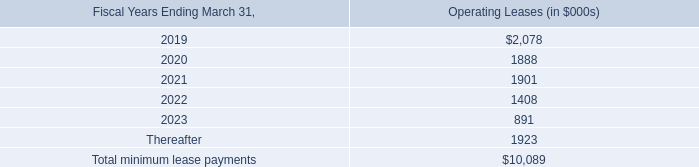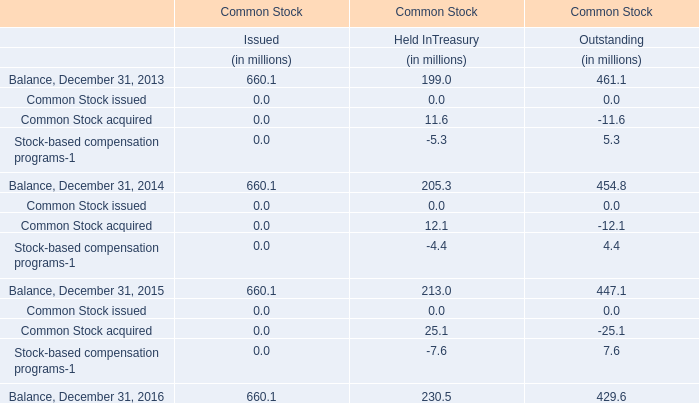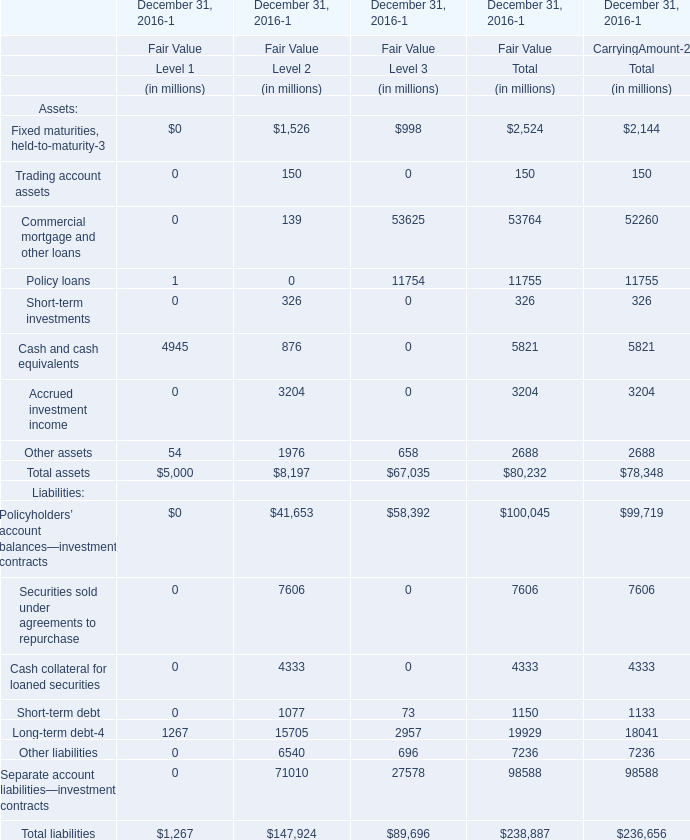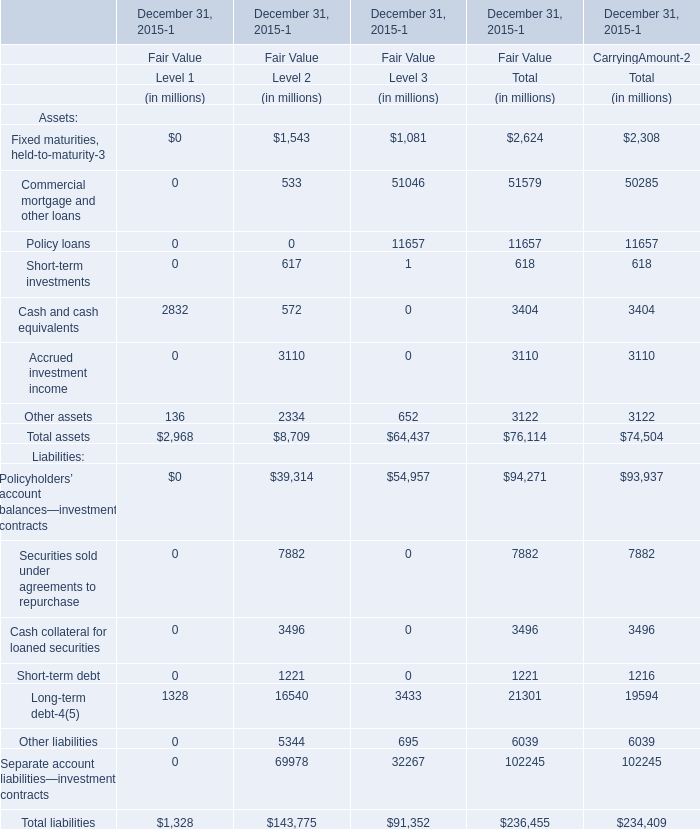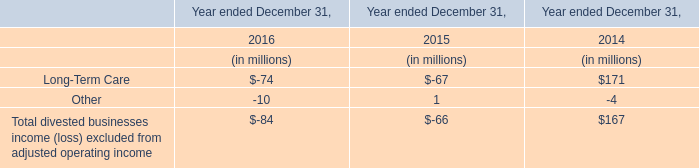What was the total amount of Level 2 in the range of 0 and 200 in 2016 for Fair Value for Assets? (in million) 
Computations: (150 + 139)
Answer: 289.0. 